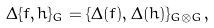<formula> <loc_0><loc_0><loc_500><loc_500>\Delta \{ f , h \} _ { G } = \{ \Delta ( f ) , \Delta ( h ) \} _ { G \otimes G } ,</formula> 